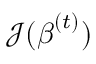<formula> <loc_0><loc_0><loc_500><loc_500>{ \mathcal { J } } ( { \beta } ^ { ( t ) } )</formula> 